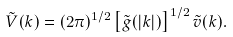Convert formula to latex. <formula><loc_0><loc_0><loc_500><loc_500>\tilde { V } ( { k } ) = ( 2 \pi ) ^ { 1 / 2 } \left [ \tilde { g } ( | { k } | ) \right ] ^ { 1 / 2 } \tilde { v } ( { k } ) .</formula> 